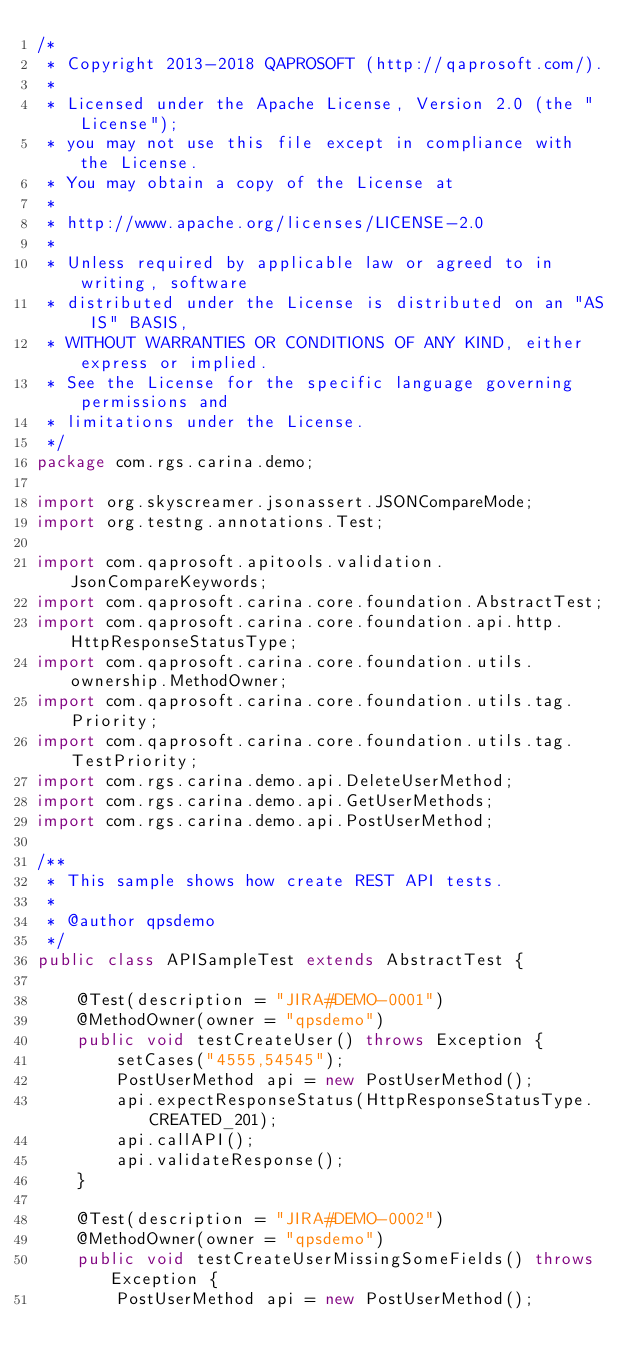<code> <loc_0><loc_0><loc_500><loc_500><_Java_>/*
 * Copyright 2013-2018 QAPROSOFT (http://qaprosoft.com/).
 *
 * Licensed under the Apache License, Version 2.0 (the "License");
 * you may not use this file except in compliance with the License.
 * You may obtain a copy of the License at
 *
 * http://www.apache.org/licenses/LICENSE-2.0
 *
 * Unless required by applicable law or agreed to in writing, software
 * distributed under the License is distributed on an "AS IS" BASIS,
 * WITHOUT WARRANTIES OR CONDITIONS OF ANY KIND, either express or implied.
 * See the License for the specific language governing permissions and
 * limitations under the License.
 */
package com.rgs.carina.demo;

import org.skyscreamer.jsonassert.JSONCompareMode;
import org.testng.annotations.Test;

import com.qaprosoft.apitools.validation.JsonCompareKeywords;
import com.qaprosoft.carina.core.foundation.AbstractTest;
import com.qaprosoft.carina.core.foundation.api.http.HttpResponseStatusType;
import com.qaprosoft.carina.core.foundation.utils.ownership.MethodOwner;
import com.qaprosoft.carina.core.foundation.utils.tag.Priority;
import com.qaprosoft.carina.core.foundation.utils.tag.TestPriority;
import com.rgs.carina.demo.api.DeleteUserMethod;
import com.rgs.carina.demo.api.GetUserMethods;
import com.rgs.carina.demo.api.PostUserMethod;

/**
 * This sample shows how create REST API tests.
 *
 * @author qpsdemo
 */
public class APISampleTest extends AbstractTest {

    @Test(description = "JIRA#DEMO-0001")
    @MethodOwner(owner = "qpsdemo")
    public void testCreateUser() throws Exception {
        setCases("4555,54545");
        PostUserMethod api = new PostUserMethod();
        api.expectResponseStatus(HttpResponseStatusType.CREATED_201);
        api.callAPI();
        api.validateResponse();
    }

    @Test(description = "JIRA#DEMO-0002")
    @MethodOwner(owner = "qpsdemo")
    public void testCreateUserMissingSomeFields() throws Exception {
        PostUserMethod api = new PostUserMethod();</code> 